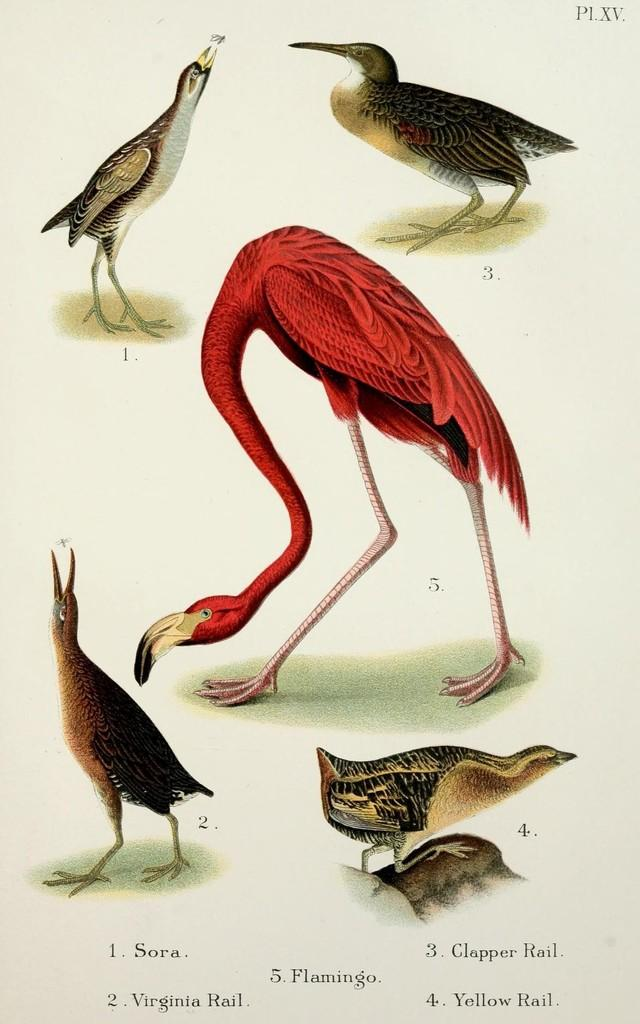What is the main subject of the picture? The main subject of the picture is images of different animals. How can the viewer identify the animals in the picture? The names of the animals are mentioned below their respective images. What type of verse can be seen written with chalk on the animals in the image? There is no verse or chalk present in the image; it only features images of animals with their names below them. 